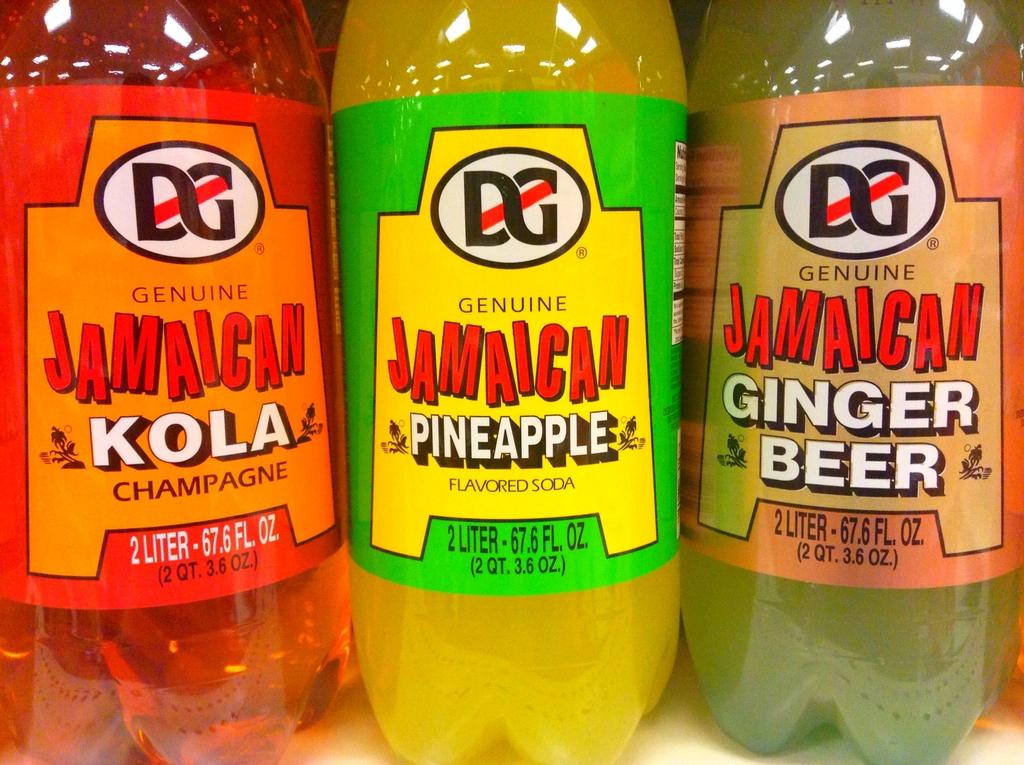How many plastic bottles are visible in the image? There are three plastic bottles in the image. Can you tell me how many lizards are holding onto the plastic bottles in the image? There are no lizards present in the image, and therefore none are holding onto the plastic bottles. 